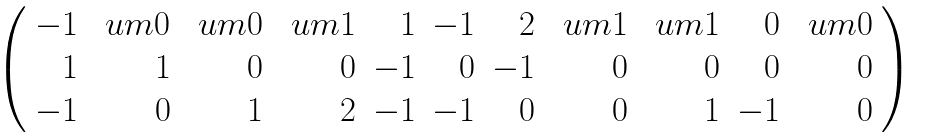<formula> <loc_0><loc_0><loc_500><loc_500>\begin{array} { c } \left ( \begin{array} { r r r r r r r r r r r } - 1 & \ u m 0 & \ u m 0 & \ u m 1 & 1 & - 1 & 2 & \ u m 1 & \ u m 1 & 0 & \ u m 0 \\ 1 & 1 & 0 & 0 & - 1 & 0 & - 1 & 0 & 0 & 0 & 0 \\ - 1 & 0 & 1 & 2 & - 1 & - 1 & 0 & 0 & 1 & - 1 & 0 \end{array} \right ) \end{array}</formula> 